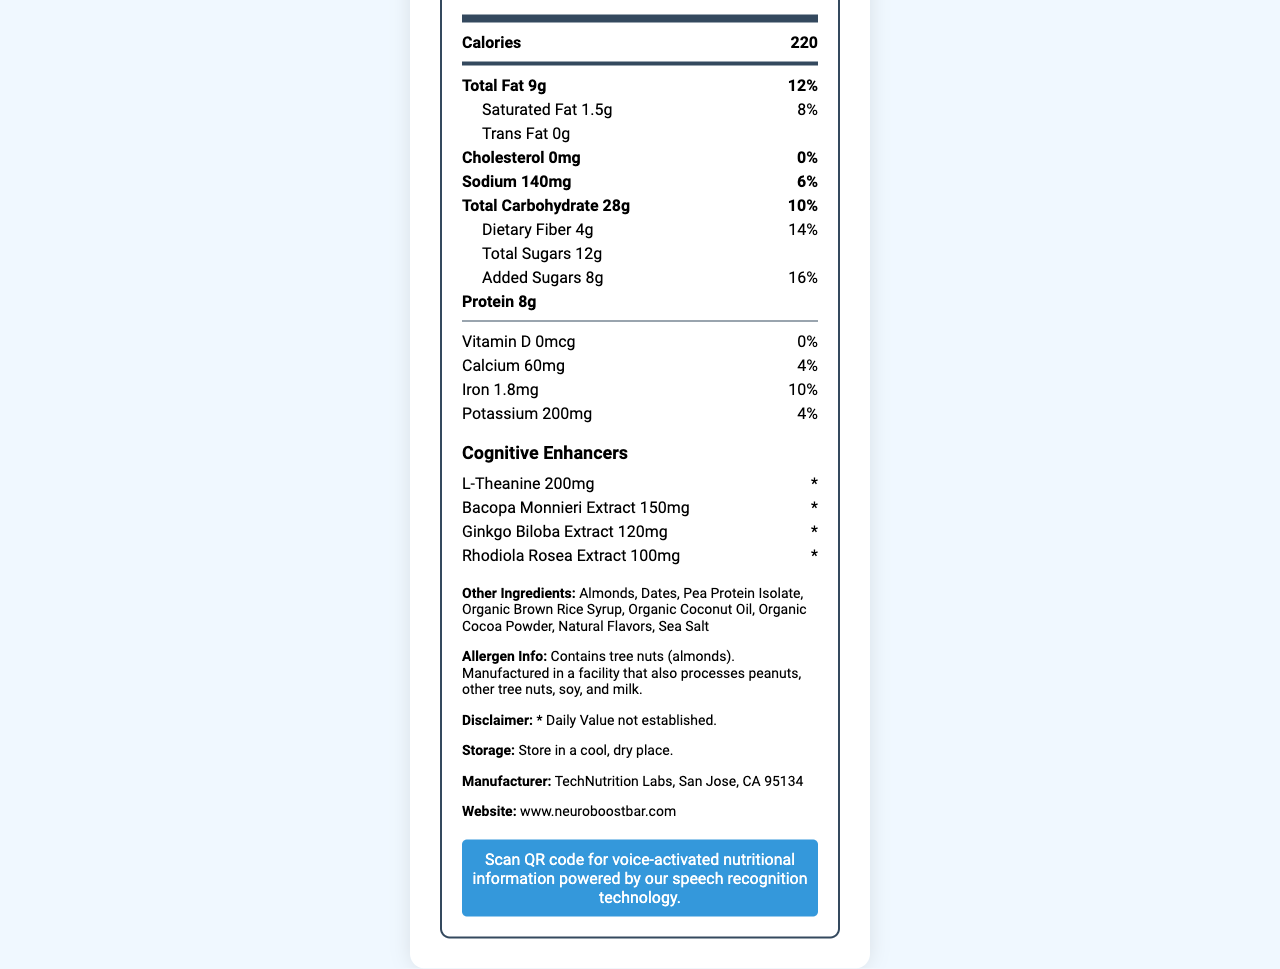what is the serving size? The serving size is mentioned under the "Nutrition Facts" section near the top of the document.
Answer: 1 bar (60g) how many calories are in one serving? The "Calories" information is provided directly below the "Nutrition Facts" header.
Answer: 220 calories what is the daily value percentage of total fat? The daily value percentage of total fat is listed next to its amount, 9g.
Answer: 12% how much saturated fat is in one serving? The amount of saturated fat is stated in the subcategory under Total Fat.
Answer: 1.5g what is the amount of dietary fiber per serving? The amount of dietary fiber is listed under the Total Carbohydrate section.
Answer: 4g which cognitive enhancer is present in the largest amount? A. L-Theanine B. Bacopa Monnieri Extract C. Ginkgo Biloba Extract D. Rhodiola Rosea Extract L-Theanine is present in the largest amount at 200mg compared to the other cognitive enhancers.
Answer: A how much sodium does one serving contain? A. 140mg B. 180mg C. 200mg D. 230mg The amount of sodium per serving is specified as 140mg.
Answer: A are there any allergens in the product? The document lists "Contains tree nuts (almonds)" in the allergen information section.
Answer: Yes which organization manufactures the product? The manufacturer information is explicitly stated towards the end of the document.
Answer: TechNutrition Labs, San Jose, CA 95134 does the product contain any trans fat? The document states "Trans Fat 0g" under the fat section.
Answer: No describe the main purpose of the document. The document is a nutrition facts label that aims to inform consumers about the nutritional content and ingredients in the NeuroBoost Bar, along with providing additional insights about allergens, storage, and technology features for improved user experience.
Answer: The document provides detailed nutrition information about the NeuroBoost Bar, which includes serving size, calories, macronutrients, micronutrients, and cognitive enhancers. It also includes additional information such as allergen warning, storage instructions, manufacturer details, and tech integration for voice-activated nutritional information. what is the specific daily value for potassium in the product? The daily value percentage for potassium is listed alongside its amount, 200mg.
Answer: 4% is the daily value for vitamin D established in the product? The document indicates "* Daily Value not established" for vitamin D, along with a disclaimer about certain enhancers.
Answer: No can the document tell us about the nearness of the nearest expiry date? There is no information about the expiry date or its proximity in the document.
Answer: Cannot be determined 